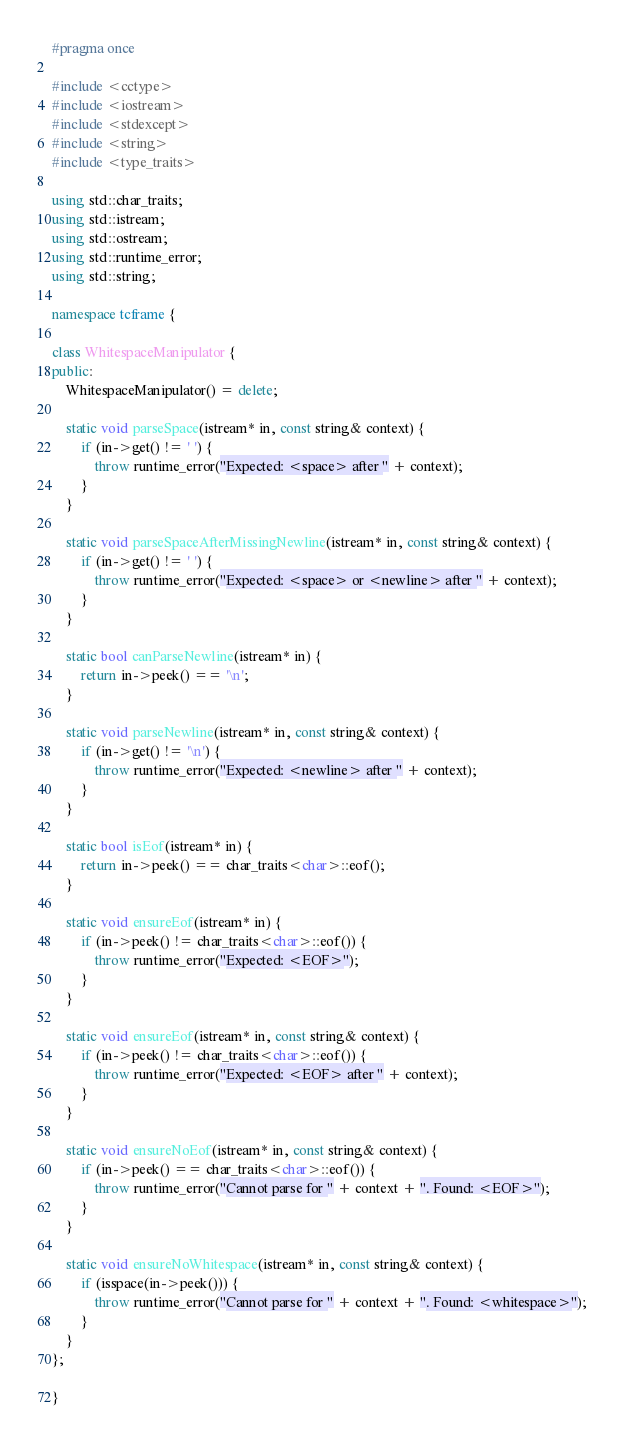Convert code to text. <code><loc_0><loc_0><loc_500><loc_500><_C++_>#pragma once

#include <cctype>
#include <iostream>
#include <stdexcept>
#include <string>
#include <type_traits>

using std::char_traits;
using std::istream;
using std::ostream;
using std::runtime_error;
using std::string;

namespace tcframe {

class WhitespaceManipulator {
public:
    WhitespaceManipulator() = delete;

    static void parseSpace(istream* in, const string& context) {
        if (in->get() != ' ') {
            throw runtime_error("Expected: <space> after " + context);
        }
    }

    static void parseSpaceAfterMissingNewline(istream* in, const string& context) {
        if (in->get() != ' ') {
            throw runtime_error("Expected: <space> or <newline> after " + context);
        }
    }

    static bool canParseNewline(istream* in) {
        return in->peek() == '\n';
    }

    static void parseNewline(istream* in, const string& context) {
        if (in->get() != '\n') {
            throw runtime_error("Expected: <newline> after " + context);
        }
    }

    static bool isEof(istream* in) {
        return in->peek() == char_traits<char>::eof();
    }

    static void ensureEof(istream* in) {
        if (in->peek() != char_traits<char>::eof()) {
            throw runtime_error("Expected: <EOF>");
        }
    }

    static void ensureEof(istream* in, const string& context) {
        if (in->peek() != char_traits<char>::eof()) {
            throw runtime_error("Expected: <EOF> after " + context);
        }
    }

    static void ensureNoEof(istream* in, const string& context) {
        if (in->peek() == char_traits<char>::eof()) {
            throw runtime_error("Cannot parse for " + context + ". Found: <EOF>");
        }
    }

    static void ensureNoWhitespace(istream* in, const string& context) {
        if (isspace(in->peek())) {
            throw runtime_error("Cannot parse for " + context + ". Found: <whitespace>");
        }
    }
};

}
</code> 